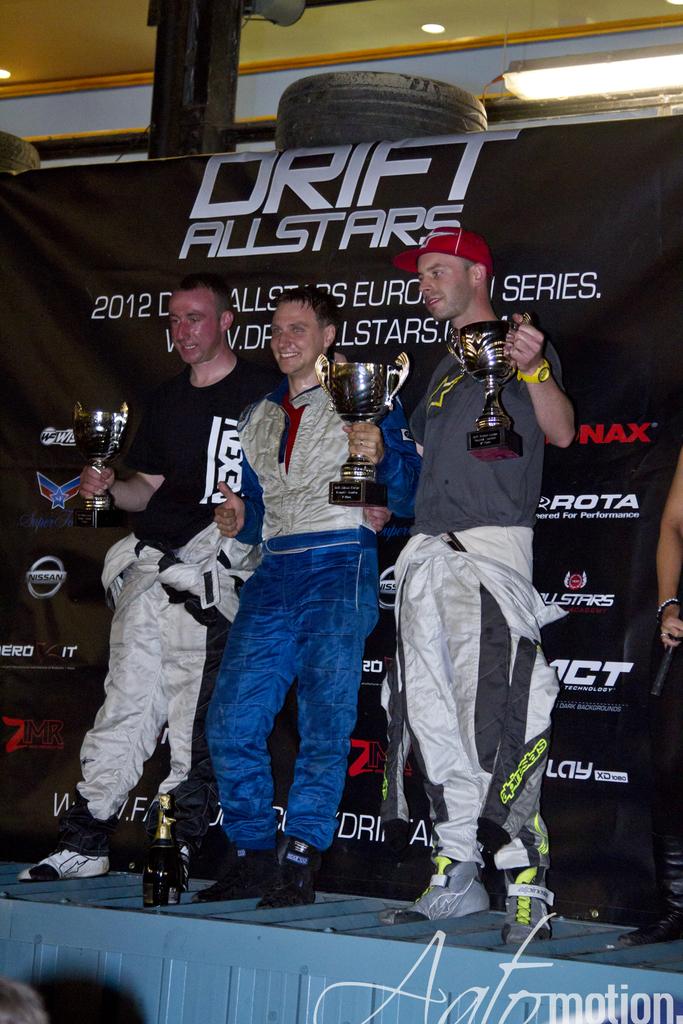What is on the banner?
Provide a short and direct response. Drift allstars. What year is cited on the backdrop?
Offer a terse response. 2012. 